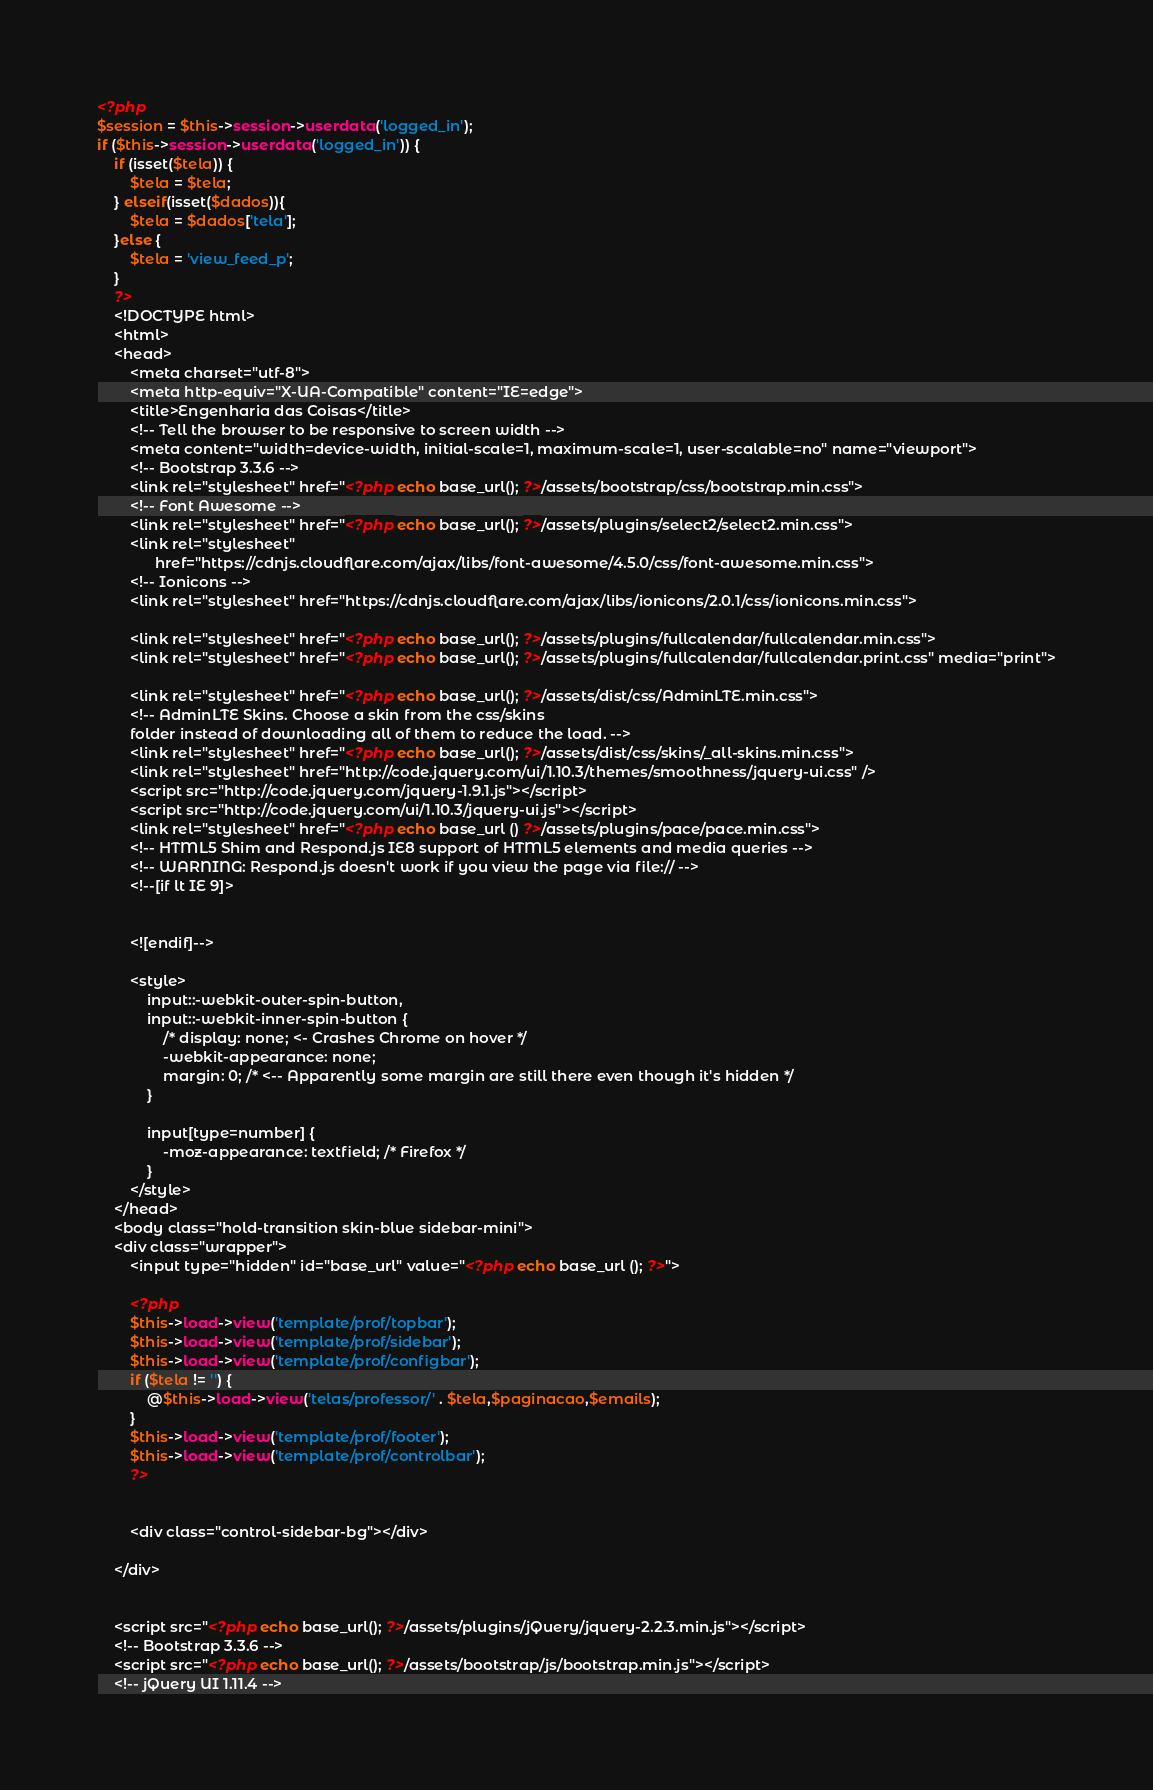Convert code to text. <code><loc_0><loc_0><loc_500><loc_500><_PHP_><?php
$session = $this->session->userdata('logged_in');
if ($this->session->userdata('logged_in')) {
	if (isset($tela)) {
		$tela = $tela;
	} elseif(isset($dados)){
		$tela = $dados['tela'];
	}else {
		$tela = 'view_feed_p';
	}
	?>
	<!DOCTYPE html>
	<html>
	<head>
		<meta charset="utf-8">
		<meta http-equiv="X-UA-Compatible" content="IE=edge">
		<title>Engenharia das Coisas</title>
		<!-- Tell the browser to be responsive to screen width -->
		<meta content="width=device-width, initial-scale=1, maximum-scale=1, user-scalable=no" name="viewport">
		<!-- Bootstrap 3.3.6 -->
		<link rel="stylesheet" href="<?php echo base_url(); ?>/assets/bootstrap/css/bootstrap.min.css">
		<!-- Font Awesome -->
		<link rel="stylesheet" href="<?php echo base_url(); ?>/assets/plugins/select2/select2.min.css">
		<link rel="stylesheet"
			  href="https://cdnjs.cloudflare.com/ajax/libs/font-awesome/4.5.0/css/font-awesome.min.css">
		<!-- Ionicons -->
		<link rel="stylesheet" href="https://cdnjs.cloudflare.com/ajax/libs/ionicons/2.0.1/css/ionicons.min.css">

		<link rel="stylesheet" href="<?php echo base_url(); ?>/assets/plugins/fullcalendar/fullcalendar.min.css">
		<link rel="stylesheet" href="<?php echo base_url(); ?>/assets/plugins/fullcalendar/fullcalendar.print.css" media="print">

		<link rel="stylesheet" href="<?php echo base_url(); ?>/assets/dist/css/AdminLTE.min.css">
		<!-- AdminLTE Skins. Choose a skin from the css/skins
		folder instead of downloading all of them to reduce the load. -->
		<link rel="stylesheet" href="<?php echo base_url(); ?>/assets/dist/css/skins/_all-skins.min.css">
		<link rel="stylesheet" href="http://code.jquery.com/ui/1.10.3/themes/smoothness/jquery-ui.css" />
		<script src="http://code.jquery.com/jquery-1.9.1.js"></script>
		<script src="http://code.jquery.com/ui/1.10.3/jquery-ui.js"></script>
		<link rel="stylesheet" href="<?php echo base_url () ?>/assets/plugins/pace/pace.min.css">
		<!-- HTML5 Shim and Respond.js IE8 support of HTML5 elements and media queries -->
		<!-- WARNING: Respond.js doesn't work if you view the page via file:// -->
		<!--[if lt IE 9]>


		<![endif]-->

		<style>
			input::-webkit-outer-spin-button,
			input::-webkit-inner-spin-button {
				/* display: none; <- Crashes Chrome on hover */
				-webkit-appearance: none;
				margin: 0; /* <-- Apparently some margin are still there even though it's hidden */
			}

			input[type=number] {
				-moz-appearance: textfield; /* Firefox */
			}
		</style>
	</head>
	<body class="hold-transition skin-blue sidebar-mini">
	<div class="wrapper">
		<input type="hidden" id="base_url" value="<?php echo base_url (); ?>">

		<?php
		$this->load->view('template/prof/topbar');
		$this->load->view('template/prof/sidebar');
		$this->load->view('template/prof/configbar');
		if ($tela != '') {
			@$this->load->view('telas/professor/' . $tela,$paginacao,$emails);
		}
		$this->load->view('template/prof/footer');
		$this->load->view('template/prof/controlbar');
		?>


		<div class="control-sidebar-bg"></div>

	</div>


	<script src="<?php echo base_url(); ?>/assets/plugins/jQuery/jquery-2.2.3.min.js"></script>
	<!-- Bootstrap 3.3.6 -->
	<script src="<?php echo base_url(); ?>/assets/bootstrap/js/bootstrap.min.js"></script>
	<!-- jQuery UI 1.11.4 --></code> 